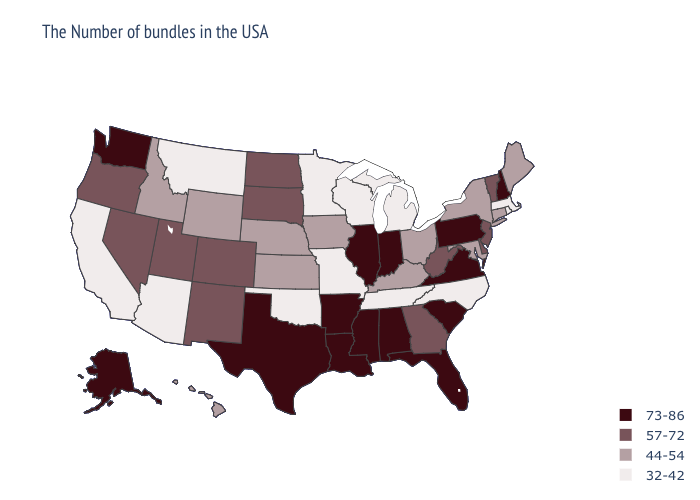What is the value of Oregon?
Keep it brief. 57-72. What is the lowest value in the West?
Concise answer only. 32-42. Does Vermont have the lowest value in the Northeast?
Give a very brief answer. No. Among the states that border Wisconsin , does Illinois have the lowest value?
Write a very short answer. No. What is the highest value in states that border Arkansas?
Concise answer only. 73-86. Name the states that have a value in the range 57-72?
Short answer required. Vermont, New Jersey, Delaware, West Virginia, Georgia, South Dakota, North Dakota, Colorado, New Mexico, Utah, Nevada, Oregon. Does Florida have the highest value in the South?
Write a very short answer. Yes. Among the states that border New Jersey , which have the lowest value?
Write a very short answer. New York. Among the states that border Kansas , does Colorado have the highest value?
Concise answer only. Yes. What is the value of Montana?
Short answer required. 32-42. What is the lowest value in states that border New Mexico?
Answer briefly. 32-42. Among the states that border Mississippi , does Tennessee have the highest value?
Write a very short answer. No. Which states hav the highest value in the Northeast?
Quick response, please. New Hampshire, Pennsylvania. Name the states that have a value in the range 44-54?
Quick response, please. Maine, Connecticut, New York, Maryland, Ohio, Kentucky, Iowa, Kansas, Nebraska, Wyoming, Idaho, Hawaii. Name the states that have a value in the range 73-86?
Short answer required. New Hampshire, Pennsylvania, Virginia, South Carolina, Florida, Indiana, Alabama, Illinois, Mississippi, Louisiana, Arkansas, Texas, Washington, Alaska. 